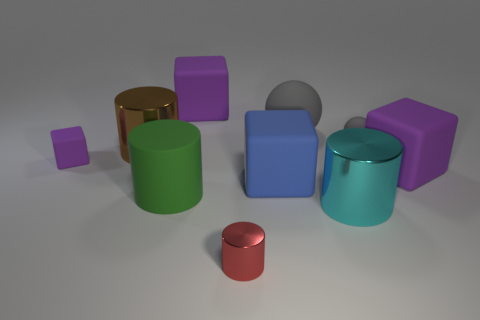Subtract all purple blocks. How many were subtracted if there are1purple blocks left? 2 Subtract all brown balls. How many purple blocks are left? 3 Subtract all cylinders. How many objects are left? 6 Subtract all cylinders. Subtract all red balls. How many objects are left? 6 Add 7 big metallic cylinders. How many big metallic cylinders are left? 9 Add 1 blue rubber objects. How many blue rubber objects exist? 2 Subtract 0 brown balls. How many objects are left? 10 